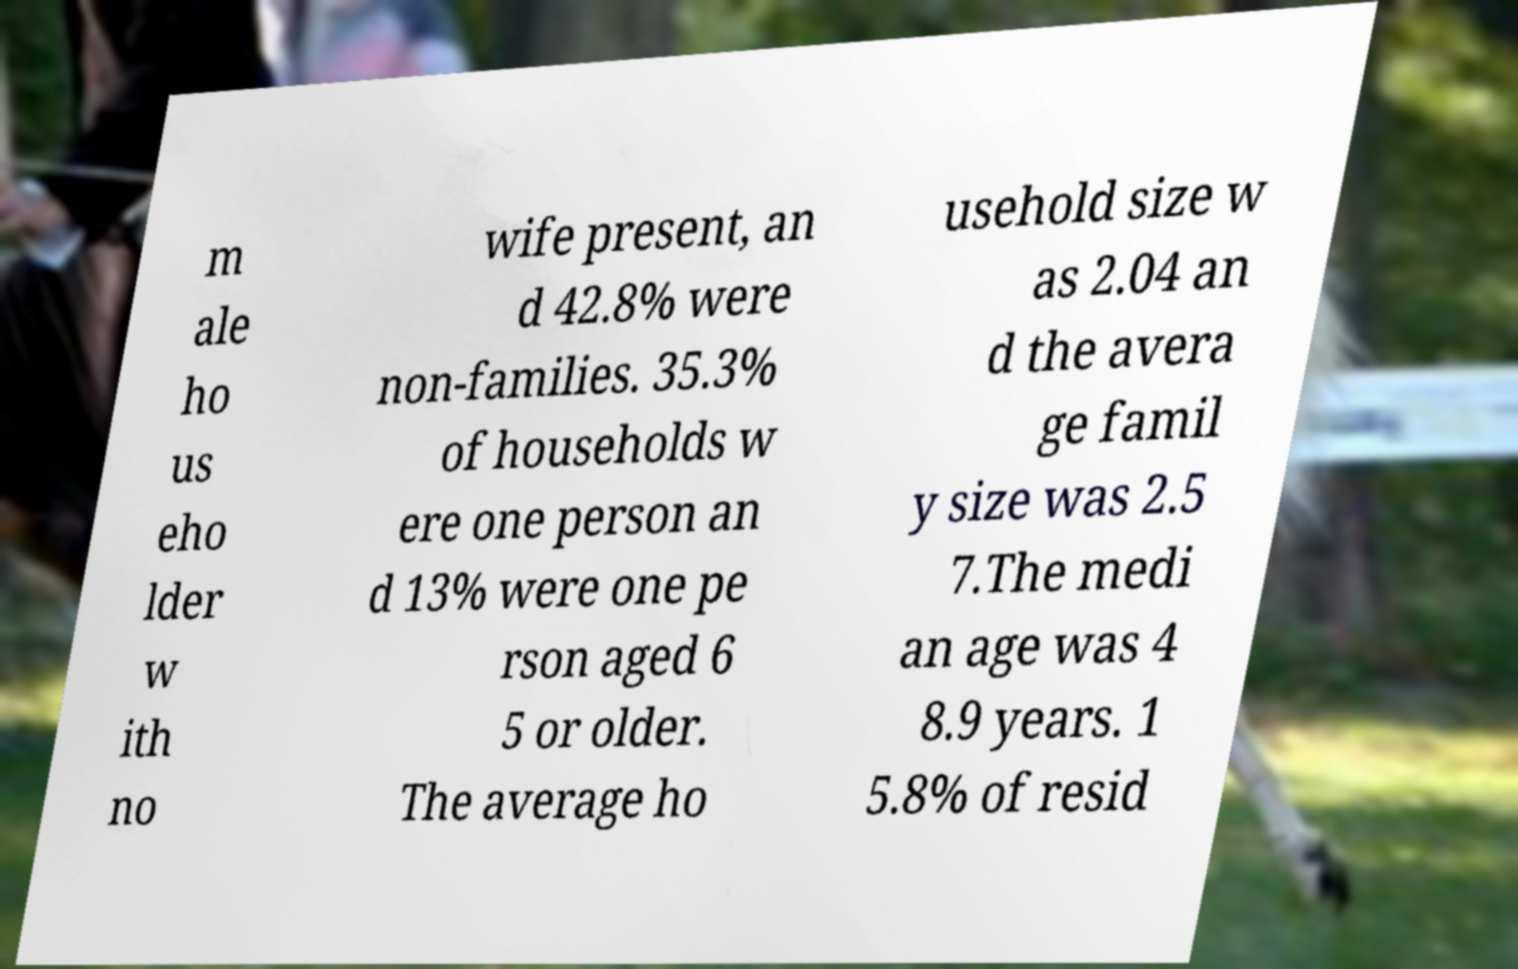Could you extract and type out the text from this image? m ale ho us eho lder w ith no wife present, an d 42.8% were non-families. 35.3% of households w ere one person an d 13% were one pe rson aged 6 5 or older. The average ho usehold size w as 2.04 an d the avera ge famil y size was 2.5 7.The medi an age was 4 8.9 years. 1 5.8% of resid 